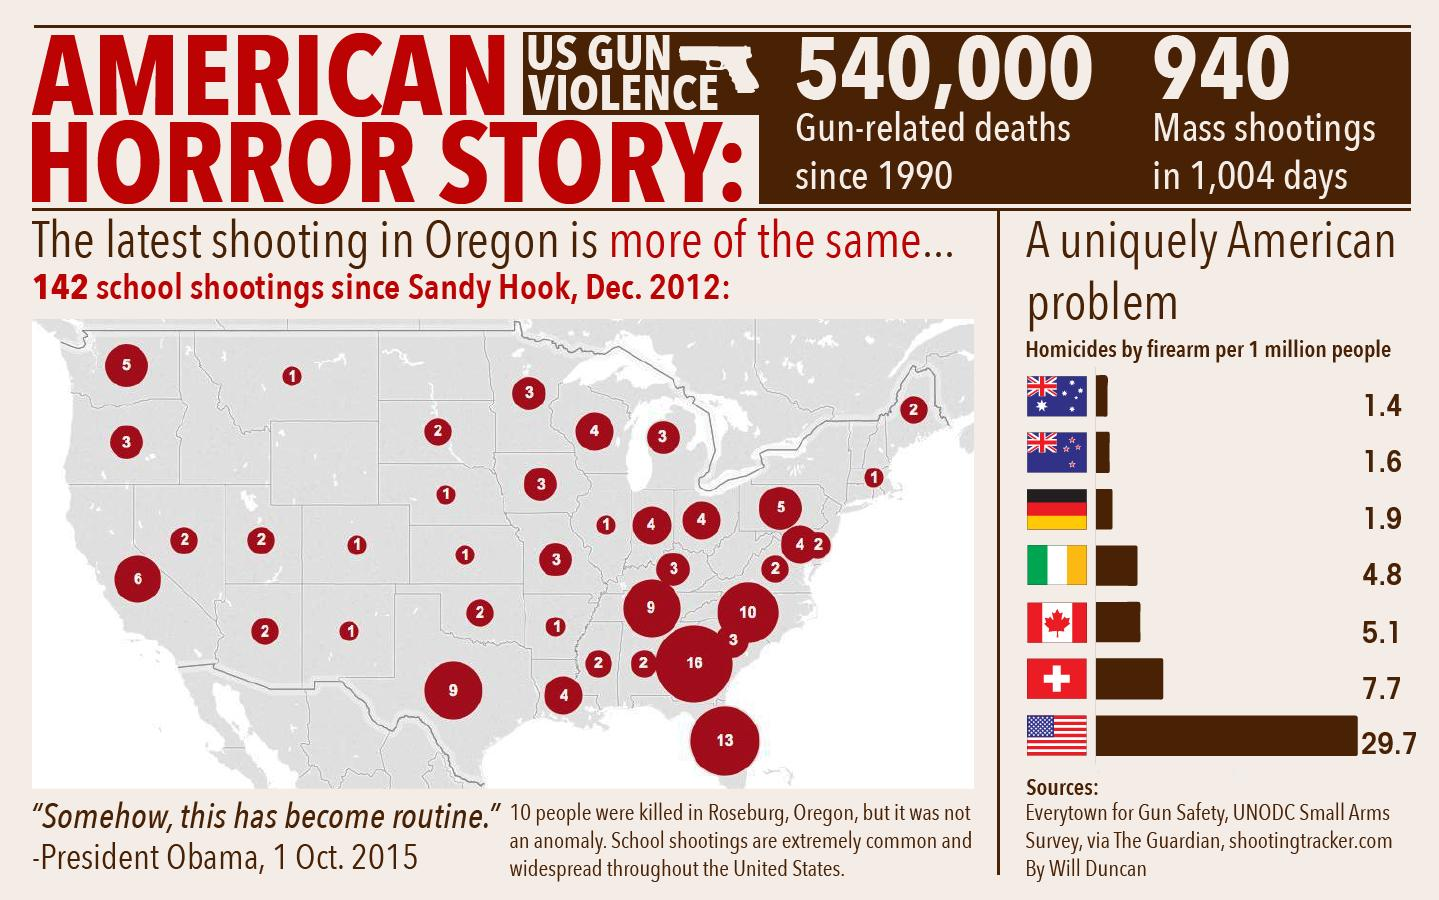Give some essential details in this illustration. The number of gun-related deaths reported in the United States since 1990 is approximately 540,000. Between the dates of January 1, 2018, and the present day, a total of 940 mass shootings have been reported in the United States. This equates to a rate of approximately 2.5 mass shootings per day. 